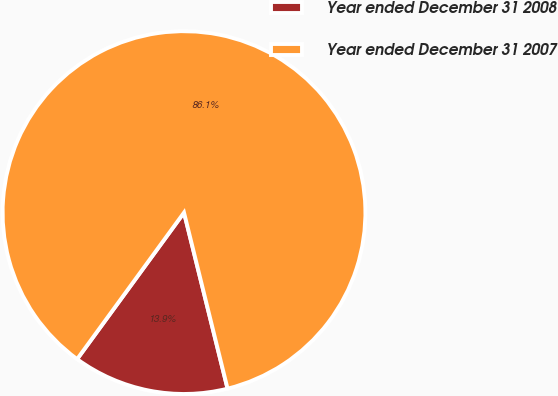<chart> <loc_0><loc_0><loc_500><loc_500><pie_chart><fcel>Year ended December 31 2008<fcel>Year ended December 31 2007<nl><fcel>13.89%<fcel>86.11%<nl></chart> 